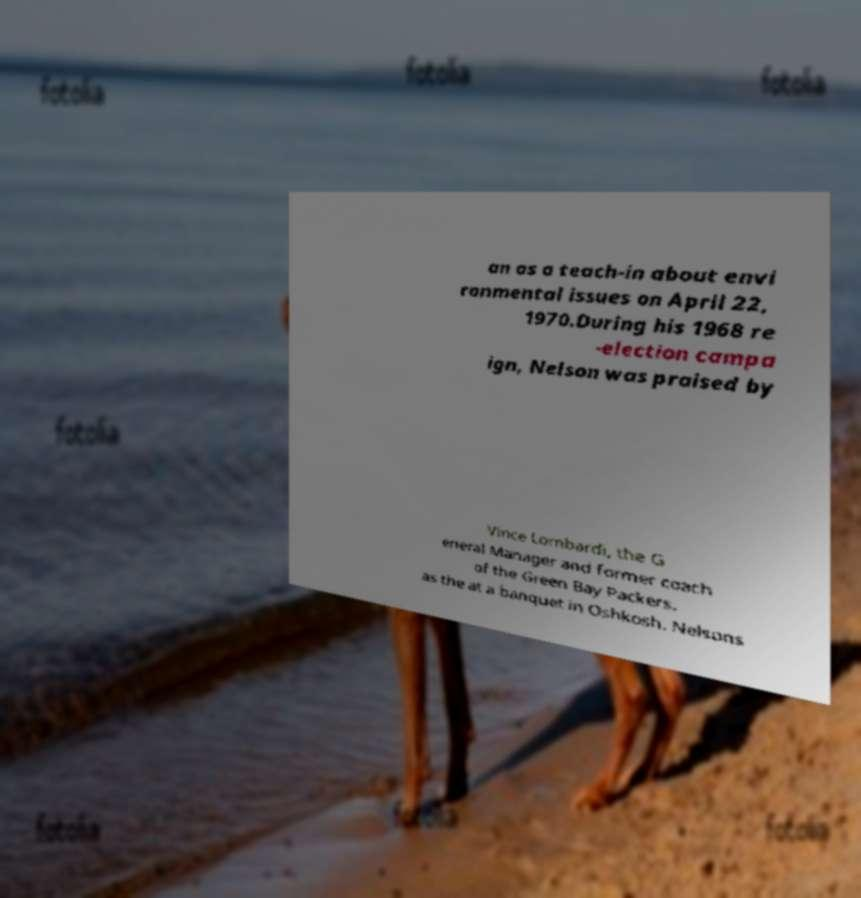There's text embedded in this image that I need extracted. Can you transcribe it verbatim? an as a teach-in about envi ronmental issues on April 22, 1970.During his 1968 re -election campa ign, Nelson was praised by Vince Lombardi, the G eneral Manager and former coach of the Green Bay Packers, as the at a banquet in Oshkosh. Nelsons 